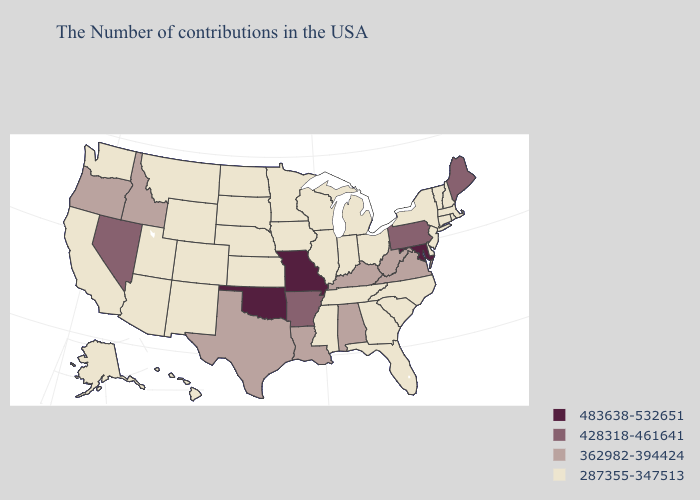Name the states that have a value in the range 483638-532651?
Give a very brief answer. Maryland, Missouri, Oklahoma. Among the states that border Indiana , which have the lowest value?
Short answer required. Ohio, Michigan, Illinois. Does Idaho have the lowest value in the USA?
Give a very brief answer. No. Does North Carolina have the same value as Maryland?
Concise answer only. No. What is the value of Pennsylvania?
Give a very brief answer. 428318-461641. What is the lowest value in states that border Louisiana?
Short answer required. 287355-347513. Name the states that have a value in the range 483638-532651?
Be succinct. Maryland, Missouri, Oklahoma. Does the map have missing data?
Keep it brief. No. What is the value of North Dakota?
Keep it brief. 287355-347513. Name the states that have a value in the range 362982-394424?
Be succinct. Virginia, West Virginia, Kentucky, Alabama, Louisiana, Texas, Idaho, Oregon. Among the states that border West Virginia , which have the highest value?
Keep it brief. Maryland. Does Pennsylvania have the highest value in the Northeast?
Be succinct. Yes. Name the states that have a value in the range 428318-461641?
Give a very brief answer. Maine, Pennsylvania, Arkansas, Nevada. Among the states that border Nevada , does Idaho have the highest value?
Keep it brief. Yes. Does Maine have a lower value than Mississippi?
Answer briefly. No. 